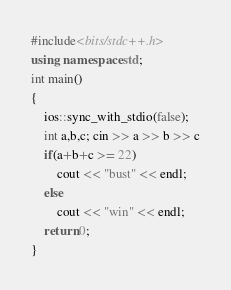<code> <loc_0><loc_0><loc_500><loc_500><_C++_>#include<bits/stdc++.h>
using namespace std;
int main()
{
    ios::sync_with_stdio(false);
    int a,b,c; cin >> a >> b >> c
    if(a+b+c >= 22)
        cout << "bust" << endl;
    else
        cout << "win" << endl;
    return 0;
}</code> 